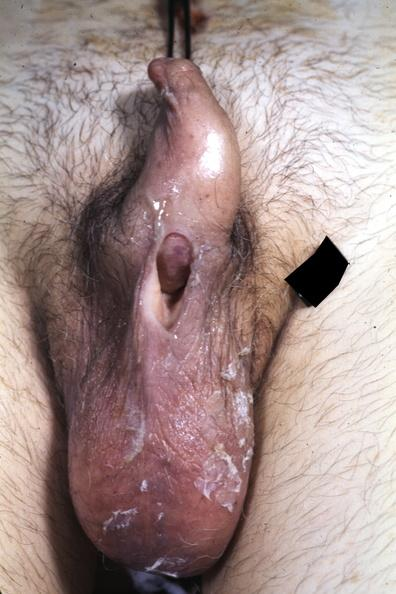s sideroblasts present?
Answer the question using a single word or phrase. No 